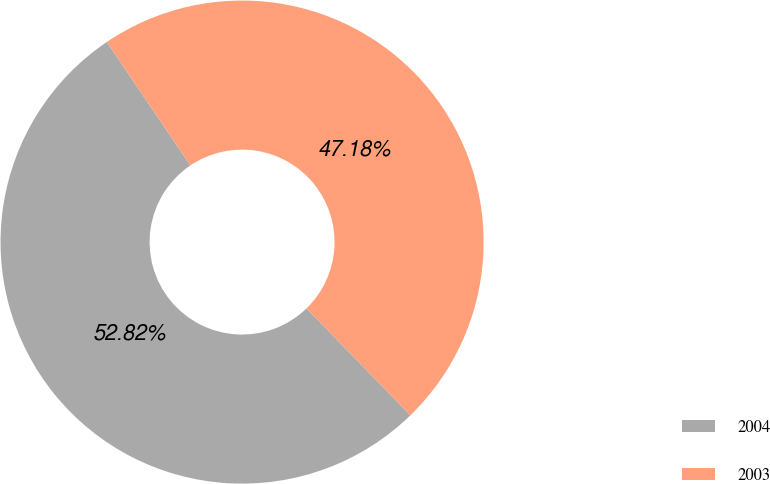Convert chart to OTSL. <chart><loc_0><loc_0><loc_500><loc_500><pie_chart><fcel>2004<fcel>2003<nl><fcel>52.82%<fcel>47.18%<nl></chart> 